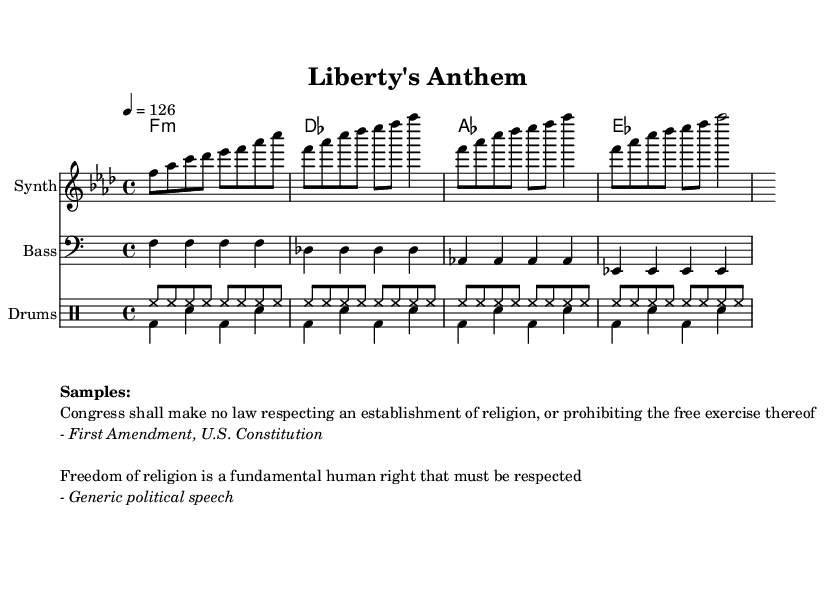What is the key signature of this music? The key signature is F minor. This is indicated at the beginning of the score, where it shows the key that dictates the notes of the melody and harmonies.
Answer: F minor What is the time signature of this music? The time signature is 4/4. This is noted at the beginning of the score, indicating there are four beats in each measure, and the quarter note receives one beat.
Answer: 4/4 What is the tempo marking for this piece? The tempo marking is 126. This is indicated in the global section, where it specifies the number of beats per minute for the pace of the performance.
Answer: 126 How many measures are in the melody? The melody consists of 8 measures. By counting the sections divided by vertical lines on the staff, we see there are 8 distinct measures presented.
Answer: 8 What type of drum pattern is used in the drums up section? The drum pattern is a hi-hat pattern. It is characterized by the repeated high-hat notes indicative of a typical electronic dance music style in this section.
Answer: Hi-hat What is the first sample used in the markup? The first sample is from the First Amendment of the U.S. Constitution, which emphasizes the freedom of religion. It is explicitly quoted in the markup section following the melody.
Answer: "Congress shall make no law respecting an establishment of religion, or prohibiting the free exercise thereof." Which instrument is designated for the melody? The instrument designated for the melody is the Synth. This is noted in the staff header where the instrument name is specified for the respective part.
Answer: Synth 